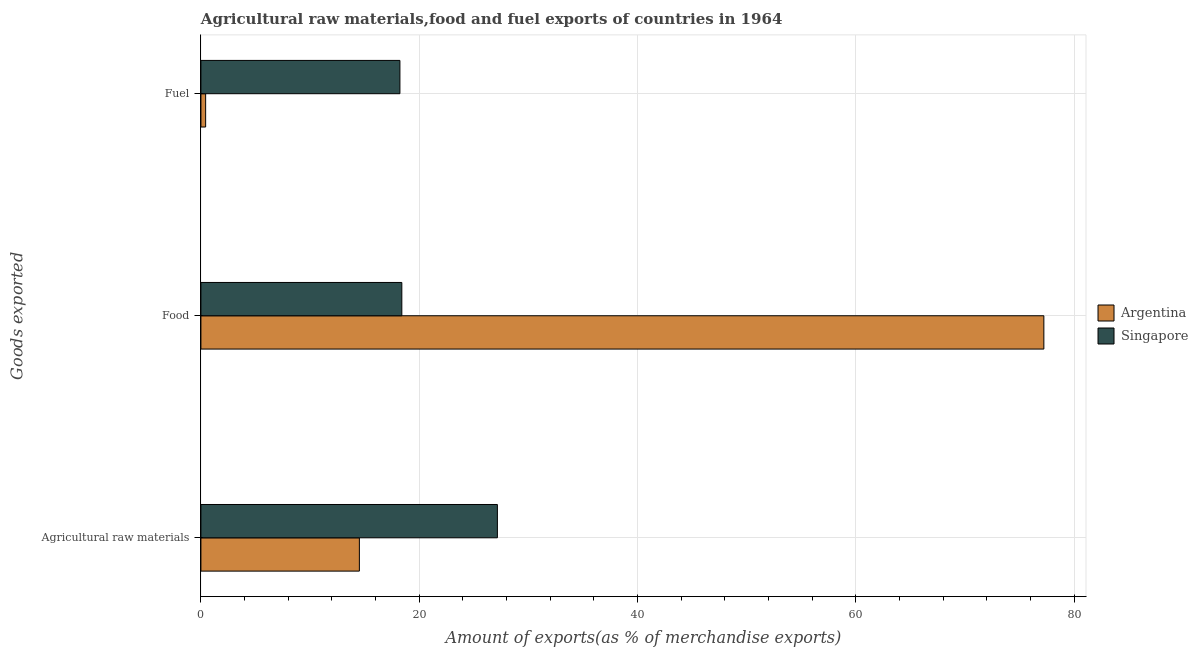How many different coloured bars are there?
Make the answer very short. 2. How many groups of bars are there?
Give a very brief answer. 3. How many bars are there on the 2nd tick from the top?
Your answer should be very brief. 2. What is the label of the 3rd group of bars from the top?
Ensure brevity in your answer.  Agricultural raw materials. What is the percentage of fuel exports in Singapore?
Make the answer very short. 18.23. Across all countries, what is the maximum percentage of raw materials exports?
Provide a succinct answer. 27.16. Across all countries, what is the minimum percentage of fuel exports?
Give a very brief answer. 0.43. In which country was the percentage of fuel exports maximum?
Keep it short and to the point. Singapore. In which country was the percentage of raw materials exports minimum?
Your answer should be very brief. Argentina. What is the total percentage of food exports in the graph?
Offer a very short reply. 95.63. What is the difference between the percentage of fuel exports in Argentina and that in Singapore?
Keep it short and to the point. -17.8. What is the difference between the percentage of fuel exports in Argentina and the percentage of food exports in Singapore?
Give a very brief answer. -17.97. What is the average percentage of raw materials exports per country?
Your response must be concise. 20.84. What is the difference between the percentage of fuel exports and percentage of food exports in Argentina?
Your response must be concise. -76.79. In how many countries, is the percentage of fuel exports greater than 28 %?
Ensure brevity in your answer.  0. What is the ratio of the percentage of fuel exports in Argentina to that in Singapore?
Give a very brief answer. 0.02. Is the percentage of raw materials exports in Argentina less than that in Singapore?
Your response must be concise. Yes. Is the difference between the percentage of food exports in Argentina and Singapore greater than the difference between the percentage of fuel exports in Argentina and Singapore?
Provide a short and direct response. Yes. What is the difference between the highest and the second highest percentage of food exports?
Your answer should be very brief. 58.82. What is the difference between the highest and the lowest percentage of food exports?
Your response must be concise. 58.82. In how many countries, is the percentage of fuel exports greater than the average percentage of fuel exports taken over all countries?
Give a very brief answer. 1. Is the sum of the percentage of fuel exports in Argentina and Singapore greater than the maximum percentage of food exports across all countries?
Make the answer very short. No. What does the 2nd bar from the top in Agricultural raw materials represents?
Your answer should be very brief. Argentina. What does the 2nd bar from the bottom in Food represents?
Offer a terse response. Singapore. Is it the case that in every country, the sum of the percentage of raw materials exports and percentage of food exports is greater than the percentage of fuel exports?
Give a very brief answer. Yes. Are all the bars in the graph horizontal?
Ensure brevity in your answer.  Yes. What is the difference between two consecutive major ticks on the X-axis?
Offer a very short reply. 20. Does the graph contain any zero values?
Ensure brevity in your answer.  No. Does the graph contain grids?
Provide a short and direct response. Yes. How many legend labels are there?
Your response must be concise. 2. What is the title of the graph?
Offer a very short reply. Agricultural raw materials,food and fuel exports of countries in 1964. Does "East Asia (developing only)" appear as one of the legend labels in the graph?
Ensure brevity in your answer.  No. What is the label or title of the X-axis?
Your response must be concise. Amount of exports(as % of merchandise exports). What is the label or title of the Y-axis?
Your response must be concise. Goods exported. What is the Amount of exports(as % of merchandise exports) of Argentina in Agricultural raw materials?
Provide a short and direct response. 14.52. What is the Amount of exports(as % of merchandise exports) of Singapore in Agricultural raw materials?
Offer a very short reply. 27.16. What is the Amount of exports(as % of merchandise exports) in Argentina in Food?
Your answer should be very brief. 77.23. What is the Amount of exports(as % of merchandise exports) of Singapore in Food?
Ensure brevity in your answer.  18.41. What is the Amount of exports(as % of merchandise exports) of Argentina in Fuel?
Your answer should be very brief. 0.43. What is the Amount of exports(as % of merchandise exports) of Singapore in Fuel?
Make the answer very short. 18.23. Across all Goods exported, what is the maximum Amount of exports(as % of merchandise exports) of Argentina?
Offer a terse response. 77.23. Across all Goods exported, what is the maximum Amount of exports(as % of merchandise exports) in Singapore?
Your answer should be very brief. 27.16. Across all Goods exported, what is the minimum Amount of exports(as % of merchandise exports) of Argentina?
Your answer should be very brief. 0.43. Across all Goods exported, what is the minimum Amount of exports(as % of merchandise exports) of Singapore?
Your answer should be very brief. 18.23. What is the total Amount of exports(as % of merchandise exports) in Argentina in the graph?
Ensure brevity in your answer.  92.18. What is the total Amount of exports(as % of merchandise exports) in Singapore in the graph?
Give a very brief answer. 63.8. What is the difference between the Amount of exports(as % of merchandise exports) in Argentina in Agricultural raw materials and that in Food?
Your answer should be compact. -62.71. What is the difference between the Amount of exports(as % of merchandise exports) of Singapore in Agricultural raw materials and that in Food?
Make the answer very short. 8.76. What is the difference between the Amount of exports(as % of merchandise exports) in Argentina in Agricultural raw materials and that in Fuel?
Offer a terse response. 14.08. What is the difference between the Amount of exports(as % of merchandise exports) of Singapore in Agricultural raw materials and that in Fuel?
Your answer should be compact. 8.93. What is the difference between the Amount of exports(as % of merchandise exports) of Argentina in Food and that in Fuel?
Offer a terse response. 76.79. What is the difference between the Amount of exports(as % of merchandise exports) of Singapore in Food and that in Fuel?
Your answer should be compact. 0.17. What is the difference between the Amount of exports(as % of merchandise exports) of Argentina in Agricultural raw materials and the Amount of exports(as % of merchandise exports) of Singapore in Food?
Give a very brief answer. -3.89. What is the difference between the Amount of exports(as % of merchandise exports) of Argentina in Agricultural raw materials and the Amount of exports(as % of merchandise exports) of Singapore in Fuel?
Keep it short and to the point. -3.72. What is the difference between the Amount of exports(as % of merchandise exports) of Argentina in Food and the Amount of exports(as % of merchandise exports) of Singapore in Fuel?
Provide a short and direct response. 58.99. What is the average Amount of exports(as % of merchandise exports) in Argentina per Goods exported?
Provide a succinct answer. 30.73. What is the average Amount of exports(as % of merchandise exports) of Singapore per Goods exported?
Your answer should be very brief. 21.27. What is the difference between the Amount of exports(as % of merchandise exports) of Argentina and Amount of exports(as % of merchandise exports) of Singapore in Agricultural raw materials?
Ensure brevity in your answer.  -12.64. What is the difference between the Amount of exports(as % of merchandise exports) in Argentina and Amount of exports(as % of merchandise exports) in Singapore in Food?
Your response must be concise. 58.82. What is the difference between the Amount of exports(as % of merchandise exports) in Argentina and Amount of exports(as % of merchandise exports) in Singapore in Fuel?
Make the answer very short. -17.8. What is the ratio of the Amount of exports(as % of merchandise exports) in Argentina in Agricultural raw materials to that in Food?
Offer a very short reply. 0.19. What is the ratio of the Amount of exports(as % of merchandise exports) of Singapore in Agricultural raw materials to that in Food?
Give a very brief answer. 1.48. What is the ratio of the Amount of exports(as % of merchandise exports) of Argentina in Agricultural raw materials to that in Fuel?
Your response must be concise. 33.58. What is the ratio of the Amount of exports(as % of merchandise exports) of Singapore in Agricultural raw materials to that in Fuel?
Your response must be concise. 1.49. What is the ratio of the Amount of exports(as % of merchandise exports) in Argentina in Food to that in Fuel?
Your answer should be very brief. 178.65. What is the ratio of the Amount of exports(as % of merchandise exports) of Singapore in Food to that in Fuel?
Provide a short and direct response. 1.01. What is the difference between the highest and the second highest Amount of exports(as % of merchandise exports) of Argentina?
Ensure brevity in your answer.  62.71. What is the difference between the highest and the second highest Amount of exports(as % of merchandise exports) of Singapore?
Provide a succinct answer. 8.76. What is the difference between the highest and the lowest Amount of exports(as % of merchandise exports) in Argentina?
Make the answer very short. 76.79. What is the difference between the highest and the lowest Amount of exports(as % of merchandise exports) of Singapore?
Offer a very short reply. 8.93. 